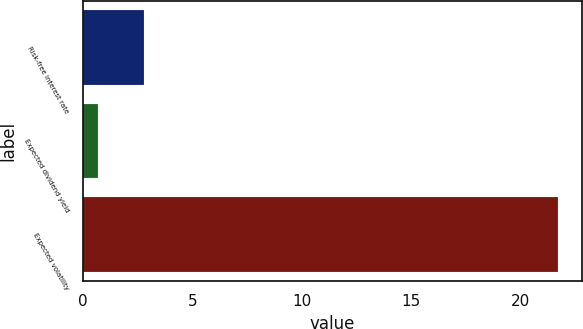Convert chart to OTSL. <chart><loc_0><loc_0><loc_500><loc_500><bar_chart><fcel>Risk-free interest rate<fcel>Expected dividend yield<fcel>Expected volatility<nl><fcel>2.81<fcel>0.71<fcel>21.74<nl></chart> 